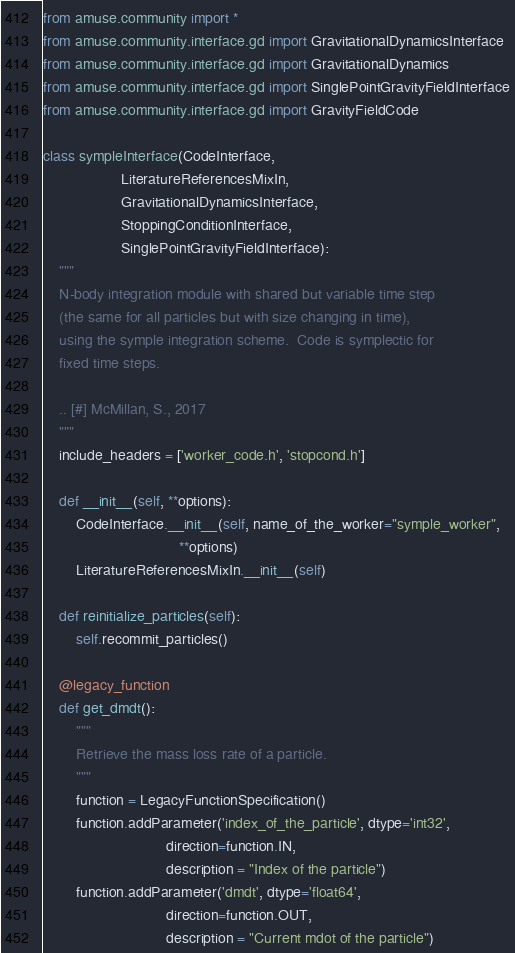Convert code to text. <code><loc_0><loc_0><loc_500><loc_500><_Python_>from amuse.community import *
from amuse.community.interface.gd import GravitationalDynamicsInterface
from amuse.community.interface.gd import GravitationalDynamics
from amuse.community.interface.gd import SinglePointGravityFieldInterface
from amuse.community.interface.gd import GravityFieldCode

class sympleInterface(CodeInterface,
                   LiteratureReferencesMixIn,
                   GravitationalDynamicsInterface,
                   StoppingConditionInterface,
                   SinglePointGravityFieldInterface):
    """
    N-body integration module with shared but variable time step
    (the same for all particles but with size changing in time),
    using the symple integration scheme.  Code is symplectic for
    fixed time steps.

    .. [#] McMillan, S., 2017
    """
    include_headers = ['worker_code.h', 'stopcond.h']

    def __init__(self, **options):
        CodeInterface.__init__(self, name_of_the_worker="symple_worker",
                                 **options)
        LiteratureReferencesMixIn.__init__(self)

    def reinitialize_particles(self):
        self.recommit_particles()

    @legacy_function
    def get_dmdt():
        """
        Retrieve the mass loss rate of a particle.
        """
        function = LegacyFunctionSpecification()
        function.addParameter('index_of_the_particle', dtype='int32',
                              direction=function.IN,
                              description = "Index of the particle")
        function.addParameter('dmdt', dtype='float64',
                              direction=function.OUT,
                              description = "Current mdot of the particle")</code> 